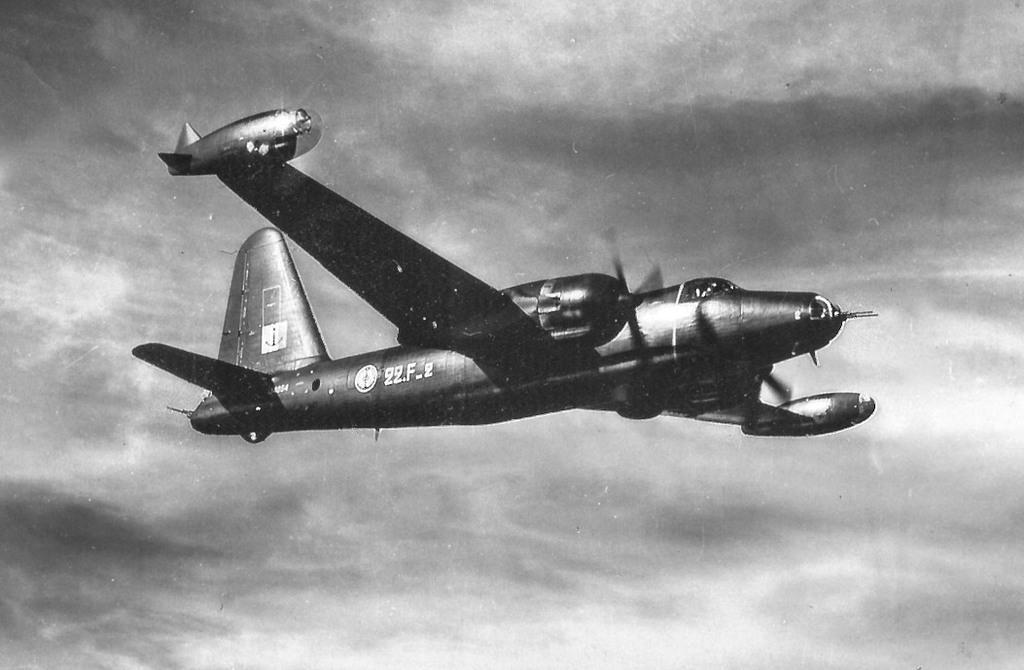Could you give a brief overview of what you see in this image? In this image I can see a black colour aircraft. I can also see few numbers are written over here and I can see this image is black and white in colour. 